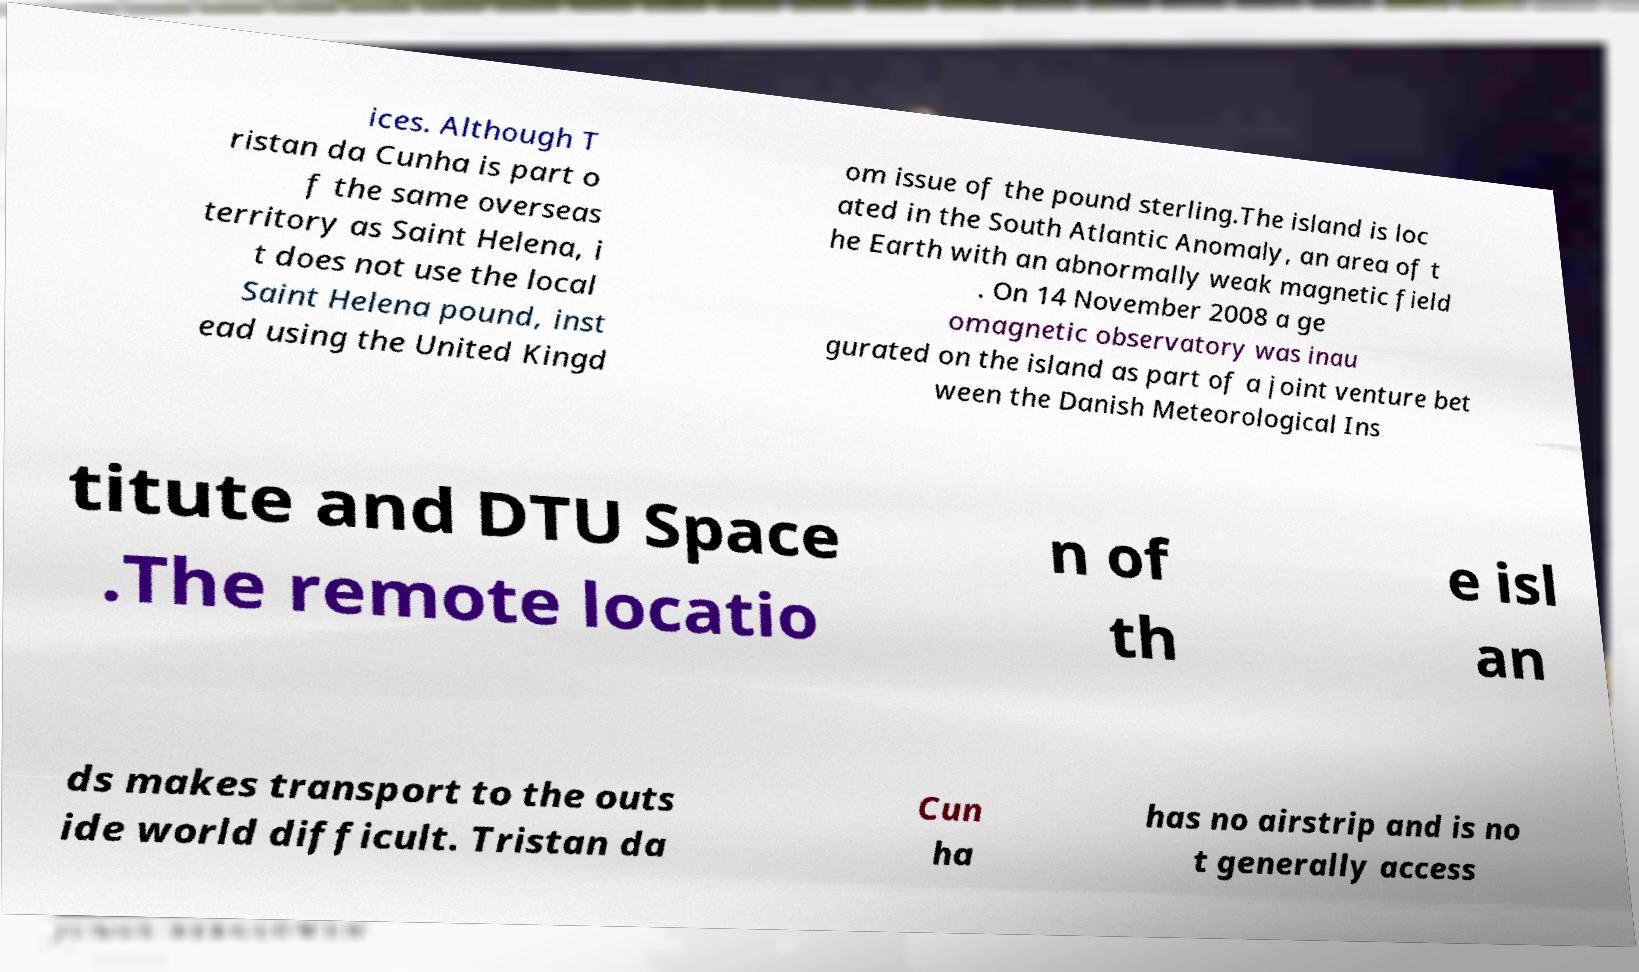Could you extract and type out the text from this image? ices. Although T ristan da Cunha is part o f the same overseas territory as Saint Helena, i t does not use the local Saint Helena pound, inst ead using the United Kingd om issue of the pound sterling.The island is loc ated in the South Atlantic Anomaly, an area of t he Earth with an abnormally weak magnetic field . On 14 November 2008 a ge omagnetic observatory was inau gurated on the island as part of a joint venture bet ween the Danish Meteorological Ins titute and DTU Space .The remote locatio n of th e isl an ds makes transport to the outs ide world difficult. Tristan da Cun ha has no airstrip and is no t generally access 